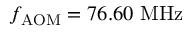<formula> <loc_0><loc_0><loc_500><loc_500>f _ { A O M } = 7 6 . 6 0 M H z</formula> 